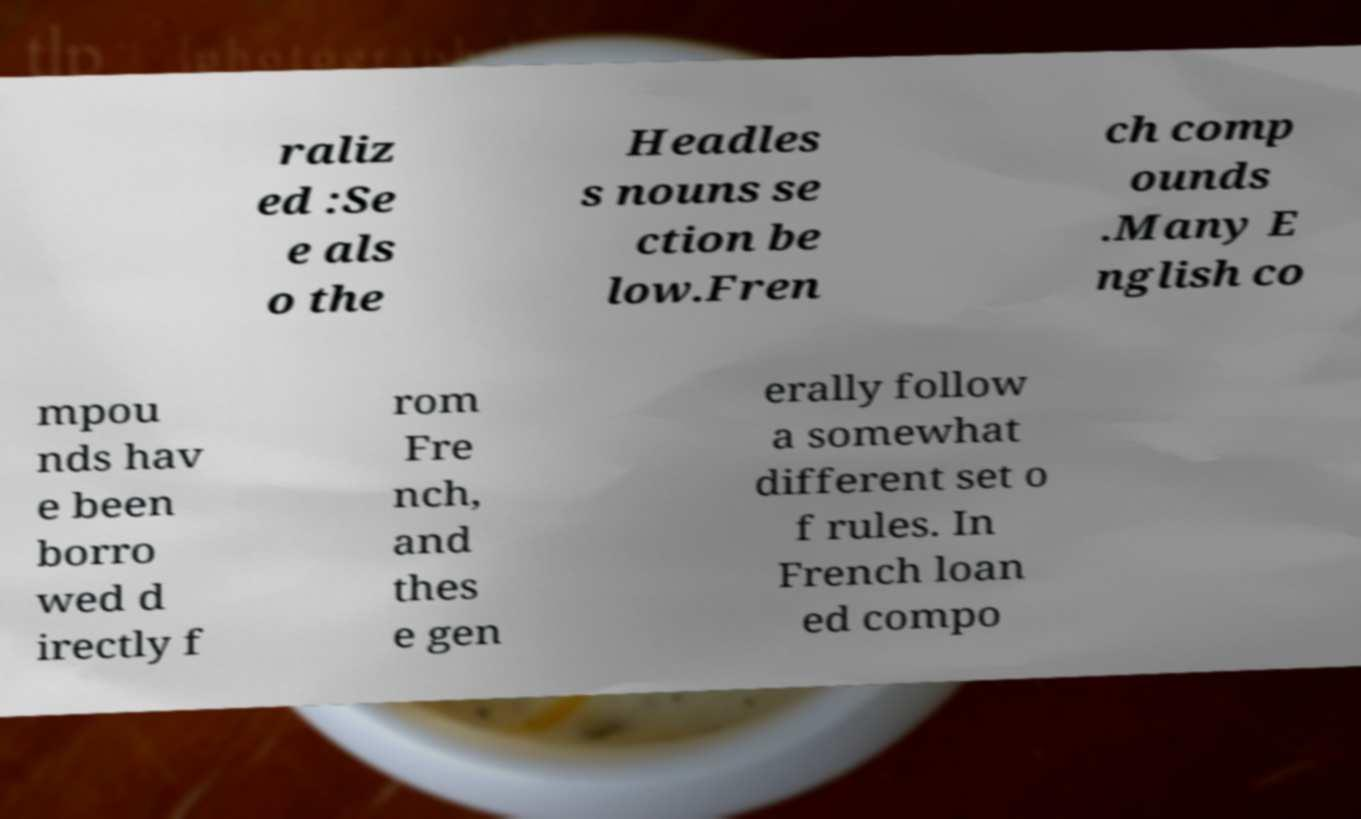Please identify and transcribe the text found in this image. raliz ed :Se e als o the Headles s nouns se ction be low.Fren ch comp ounds .Many E nglish co mpou nds hav e been borro wed d irectly f rom Fre nch, and thes e gen erally follow a somewhat different set o f rules. In French loan ed compo 